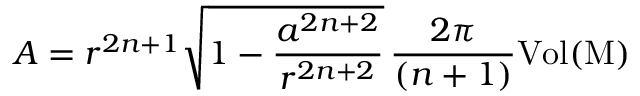Convert formula to latex. <formula><loc_0><loc_0><loc_500><loc_500>A = r ^ { 2 n + 1 } \sqrt { 1 - \frac { a ^ { 2 n + 2 } } { r ^ { 2 n + 2 } } } \, \frac { 2 \pi } { ( n + 1 ) } { V o l { ( M ) } }</formula> 